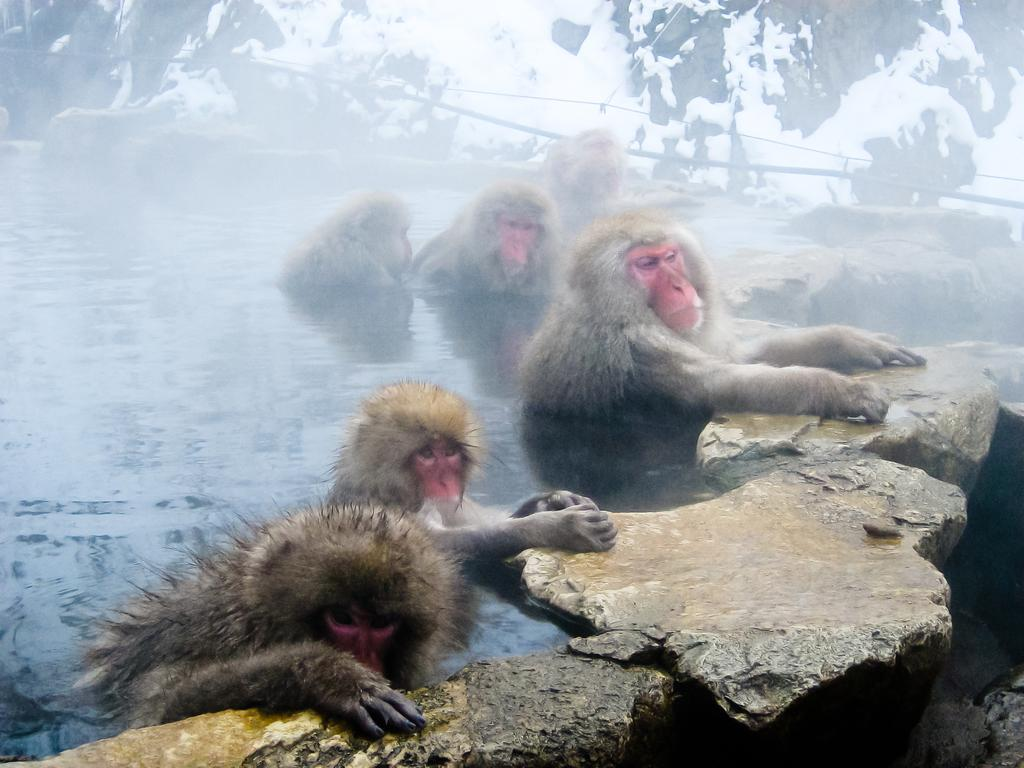What type of animals are in the water in the image? There are monkeys in the water in the image. What else can be seen in the image besides the monkeys? There are rocks visible in the image. Where is the church located in the image? There is no church present in the image. What type of throne is visible in the image? There is no throne present in the image. 